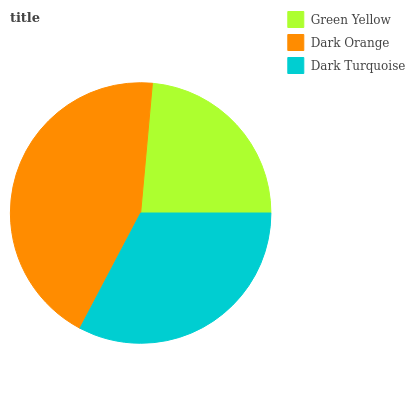Is Green Yellow the minimum?
Answer yes or no. Yes. Is Dark Orange the maximum?
Answer yes or no. Yes. Is Dark Turquoise the minimum?
Answer yes or no. No. Is Dark Turquoise the maximum?
Answer yes or no. No. Is Dark Orange greater than Dark Turquoise?
Answer yes or no. Yes. Is Dark Turquoise less than Dark Orange?
Answer yes or no. Yes. Is Dark Turquoise greater than Dark Orange?
Answer yes or no. No. Is Dark Orange less than Dark Turquoise?
Answer yes or no. No. Is Dark Turquoise the high median?
Answer yes or no. Yes. Is Dark Turquoise the low median?
Answer yes or no. Yes. Is Dark Orange the high median?
Answer yes or no. No. Is Green Yellow the low median?
Answer yes or no. No. 